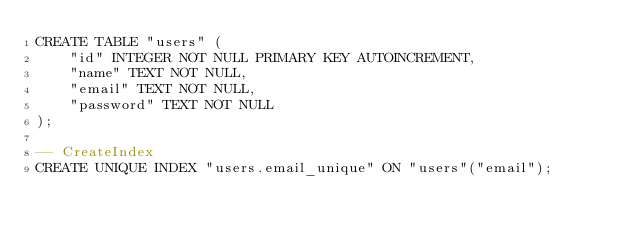Convert code to text. <code><loc_0><loc_0><loc_500><loc_500><_SQL_>CREATE TABLE "users" (
    "id" INTEGER NOT NULL PRIMARY KEY AUTOINCREMENT,
    "name" TEXT NOT NULL,
    "email" TEXT NOT NULL,
    "password" TEXT NOT NULL
);

-- CreateIndex
CREATE UNIQUE INDEX "users.email_unique" ON "users"("email");
</code> 